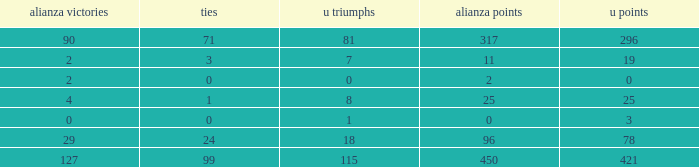Can you parse all the data within this table? {'header': ['alianza victories', 'ties', 'u triumphs', 'alianza points', 'u points'], 'rows': [['90', '71', '81', '317', '296'], ['2', '3', '7', '11', '19'], ['2', '0', '0', '2', '0'], ['4', '1', '8', '25', '25'], ['0', '0', '1', '0', '3'], ['29', '24', '18', '96', '78'], ['127', '99', '115', '450', '421']]} What is the total number of U Wins, when Alianza Goals is "0", and when U Goals is greater than 3? 0.0. 